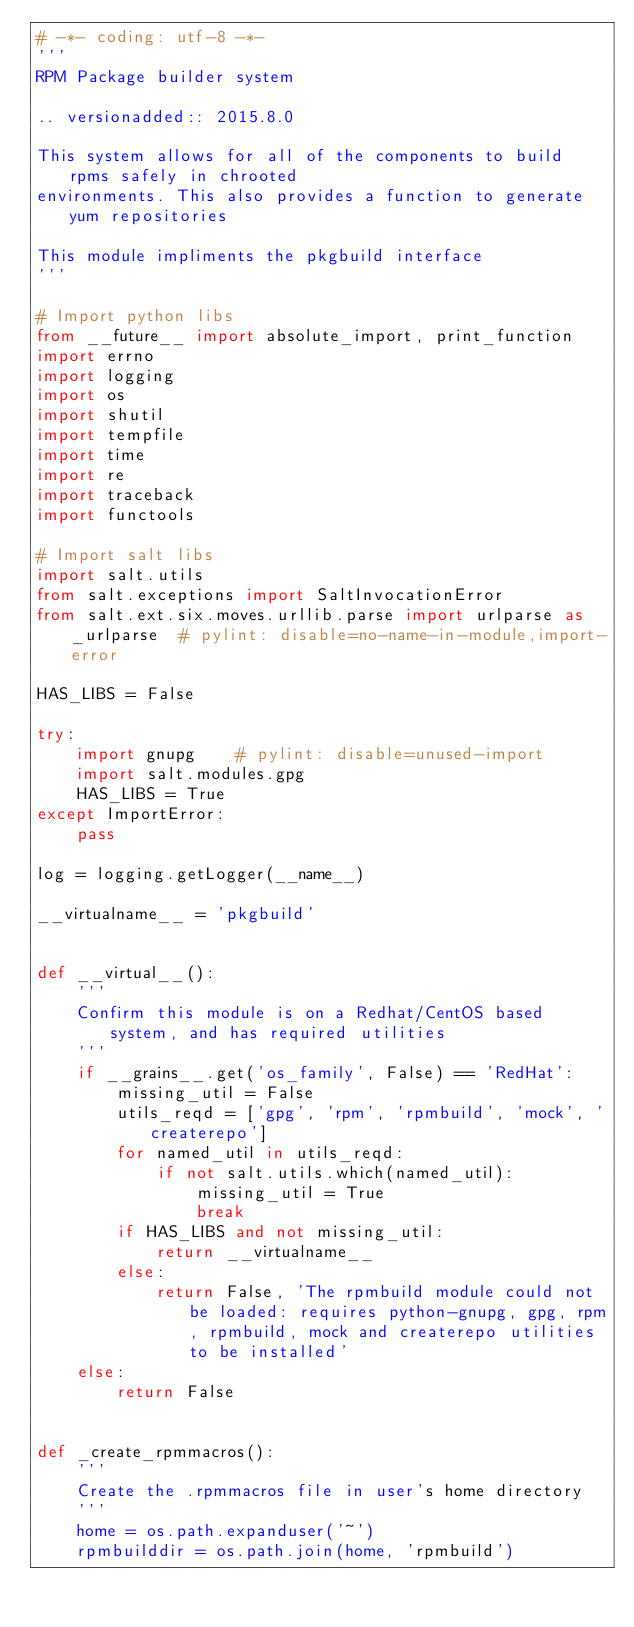Convert code to text. <code><loc_0><loc_0><loc_500><loc_500><_Python_># -*- coding: utf-8 -*-
'''
RPM Package builder system

.. versionadded:: 2015.8.0

This system allows for all of the components to build rpms safely in chrooted
environments. This also provides a function to generate yum repositories

This module impliments the pkgbuild interface
'''

# Import python libs
from __future__ import absolute_import, print_function
import errno
import logging
import os
import shutil
import tempfile
import time
import re
import traceback
import functools

# Import salt libs
import salt.utils
from salt.exceptions import SaltInvocationError
from salt.ext.six.moves.urllib.parse import urlparse as _urlparse  # pylint: disable=no-name-in-module,import-error

HAS_LIBS = False

try:
    import gnupg    # pylint: disable=unused-import
    import salt.modules.gpg
    HAS_LIBS = True
except ImportError:
    pass

log = logging.getLogger(__name__)

__virtualname__ = 'pkgbuild'


def __virtual__():
    '''
    Confirm this module is on a Redhat/CentOS based system, and has required utilities
    '''
    if __grains__.get('os_family', False) == 'RedHat':
        missing_util = False
        utils_reqd = ['gpg', 'rpm', 'rpmbuild', 'mock', 'createrepo']
        for named_util in utils_reqd:
            if not salt.utils.which(named_util):
                missing_util = True
                break
        if HAS_LIBS and not missing_util:
            return __virtualname__
        else:
            return False, 'The rpmbuild module could not be loaded: requires python-gnupg, gpg, rpm, rpmbuild, mock and createrepo utilities to be installed'
    else:
        return False


def _create_rpmmacros():
    '''
    Create the .rpmmacros file in user's home directory
    '''
    home = os.path.expanduser('~')
    rpmbuilddir = os.path.join(home, 'rpmbuild')</code> 